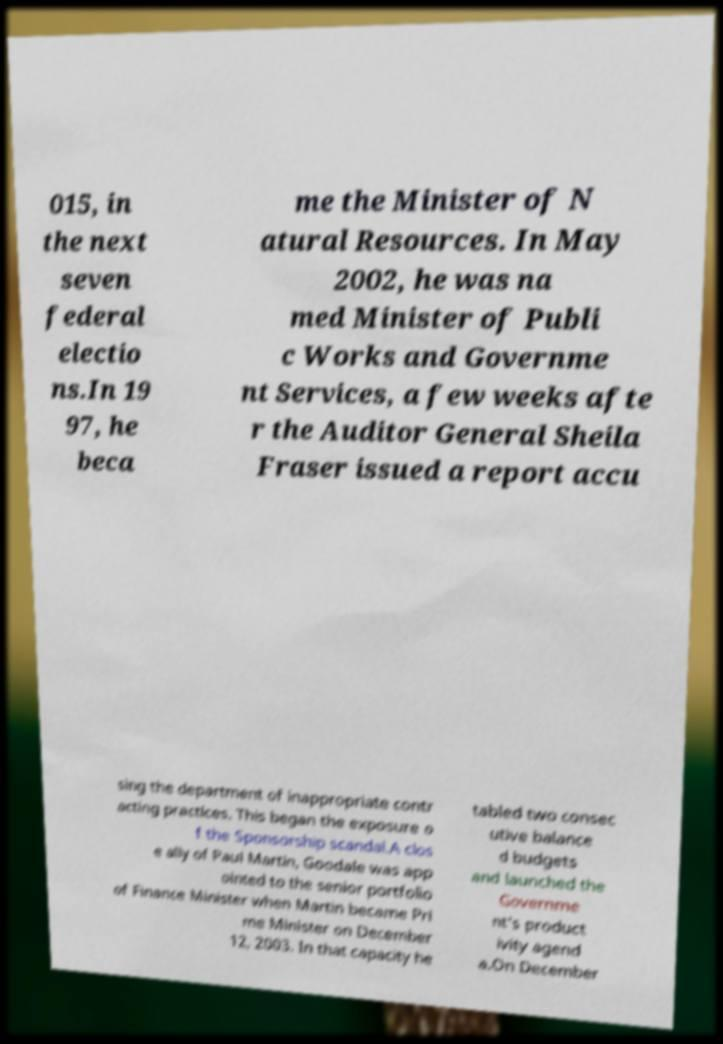What messages or text are displayed in this image? I need them in a readable, typed format. 015, in the next seven federal electio ns.In 19 97, he beca me the Minister of N atural Resources. In May 2002, he was na med Minister of Publi c Works and Governme nt Services, a few weeks afte r the Auditor General Sheila Fraser issued a report accu sing the department of inappropriate contr acting practices. This began the exposure o f the Sponsorship scandal.A clos e ally of Paul Martin, Goodale was app ointed to the senior portfolio of Finance Minister when Martin became Pri me Minister on December 12, 2003. In that capacity he tabled two consec utive balance d budgets and launched the Governme nt's product ivity agend a.On December 